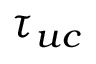<formula> <loc_0><loc_0><loc_500><loc_500>\tau _ { u c }</formula> 